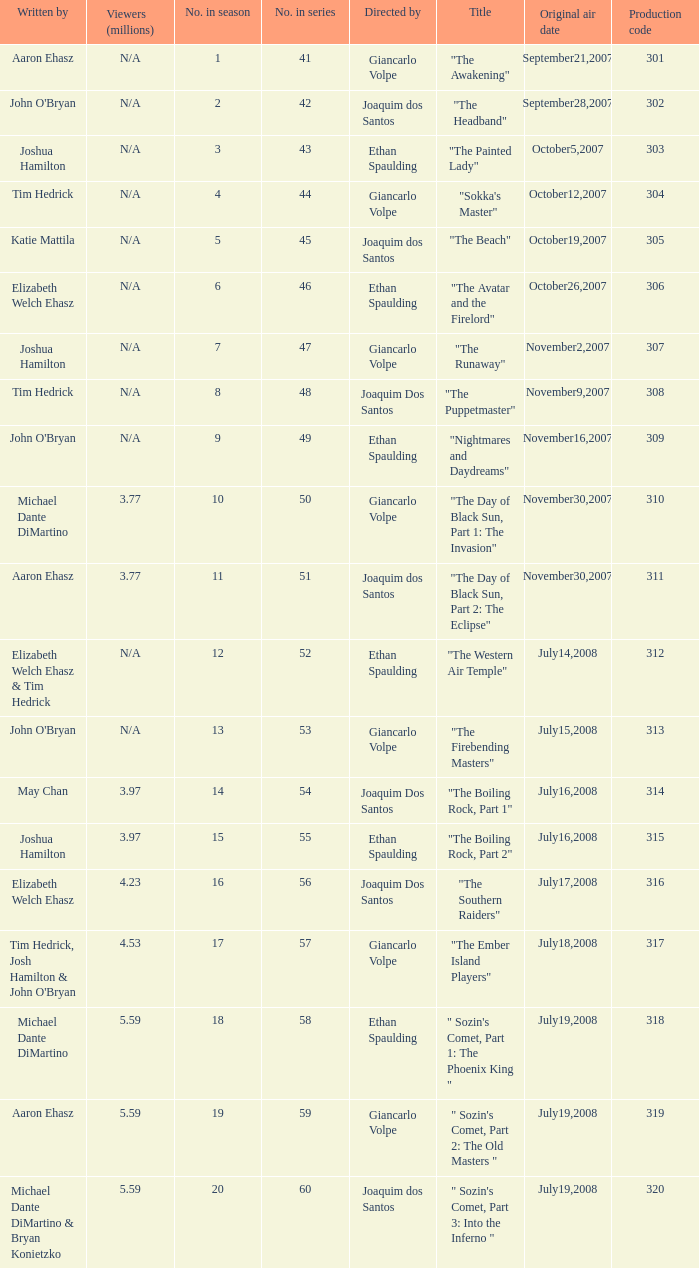How many viewers in millions for episode "sokka's master"? N/A. 